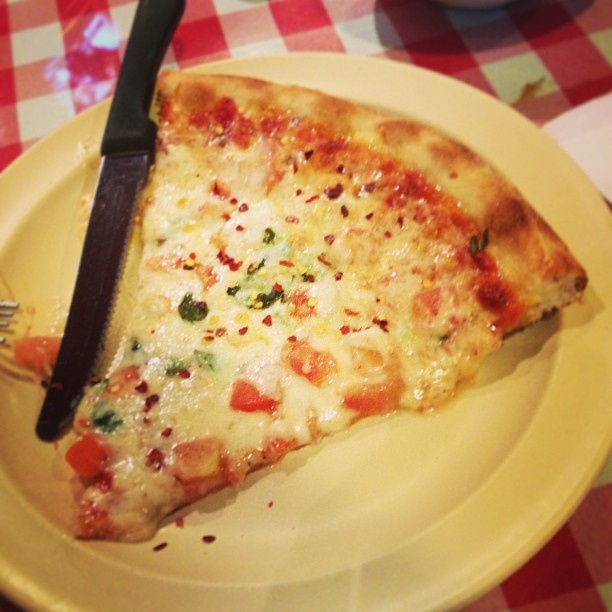Describe the objects in this image and their specific colors. I can see pizza in brown, tan, khaki, and red tones, dining table in brown, tan, and maroon tones, knife in brown, black, and maroon tones, and dining table in brown, maroon, orange, olive, and tan tones in this image. 